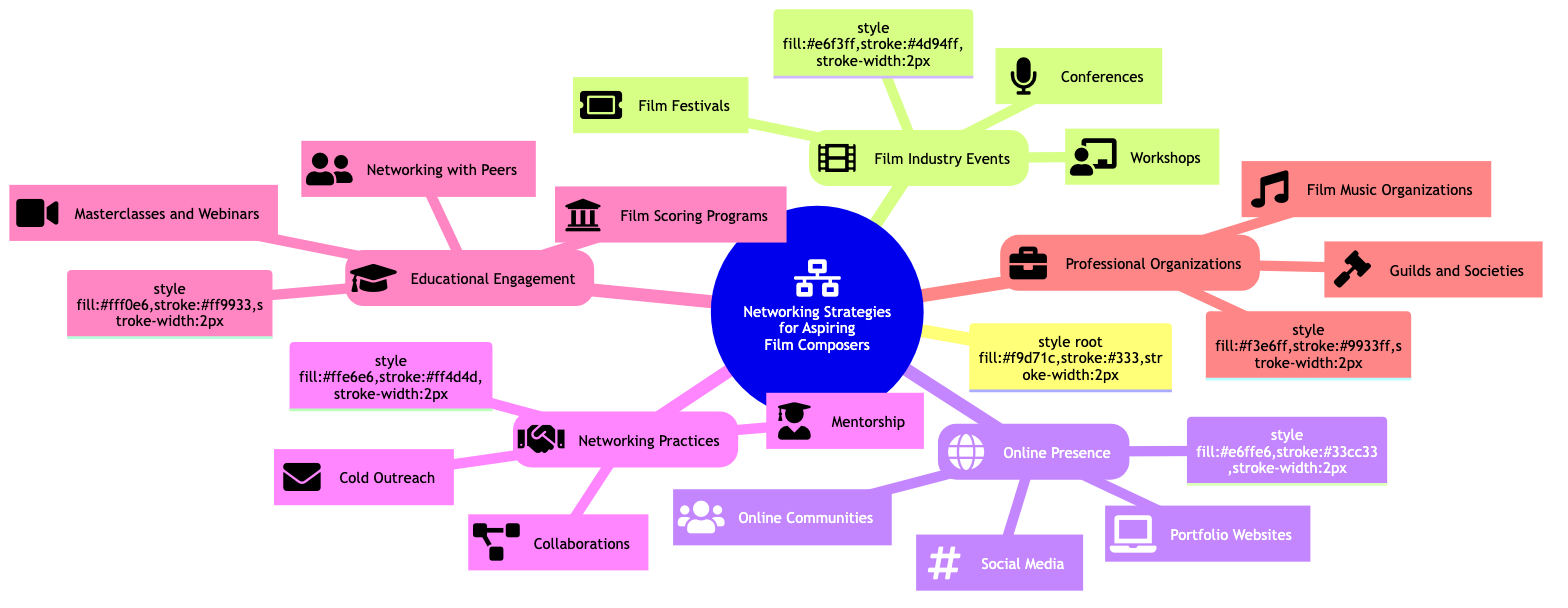What are the three main categories of networking strategies for aspiring film composers? The three main categories are Film Industry Events, Online Presence, and Networking Practices, each representing a different aspect of building relationships in the film industry.
Answer: Film Industry Events, Online Presence, Networking Practices How many film festivals are listed under Film Industry Events? Under the Film Festivals node, there are three specific film festivals mentioned: Cannes Film Festival, Sundance Film Festival, and Toronto International Film Festival.
Answer: 3 What type of online presence is suggested for aspiring film composers? The Online Presence category contains three subcategories: Social Media, Portfolio Websites, and Online Communities. Each serves a specific purpose for composers to showcase their work and connect with others.
Answer: Social Media, Portfolio Websites, Online Communities Which professional organization focuses on the rights of composers and authors? The American Society of Composers, Authors and Publishers (ASCAP) is specifically dedicated to representing the rights and interests of composers and authors in the industry.
Answer: ASCAP What are two types of networking practices mentioned? The Networking Practices category includes Collaborations and Mentorship as two key methods for aspiring film composers to build connections and gain experience.
Answer: Collaborations, Mentorship How many workshops are listed under Film Industry Events? In the Workshops section, two workshops are mentioned: ASCAP Film Scoring Workshop and BMI Film Scoring Workshop, providing hands-on learning opportunities for composers.
Answer: 2 What is one suggested method of cold outreach in Networking Practices? One method of cold outreach listed is Emailing Directors, which is a direct way to connect with potential collaborators and get noticed by industry professionals.
Answer: Emailing Directors Which film scoring program is included in the Educational Engagement category? The USC Thornton School of Music is one of the prominent film scoring programs mentioned under Educational Engagement, recognized for training in film composition.
Answer: USC Thornton School of Music What type of events is South by Southwest (SXSW)? South by Southwest (SXSW) is categorized as a Conference under Film Industry Events, known for its convergence of film, music, and interactive media.
Answer: Conference 